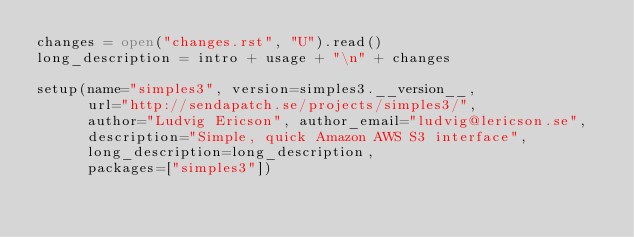<code> <loc_0><loc_0><loc_500><loc_500><_Python_>changes = open("changes.rst", "U").read()
long_description = intro + usage + "\n" + changes

setup(name="simples3", version=simples3.__version__,
      url="http://sendapatch.se/projects/simples3/",
      author="Ludvig Ericson", author_email="ludvig@lericson.se",
      description="Simple, quick Amazon AWS S3 interface",
      long_description=long_description,
      packages=["simples3"])
</code> 